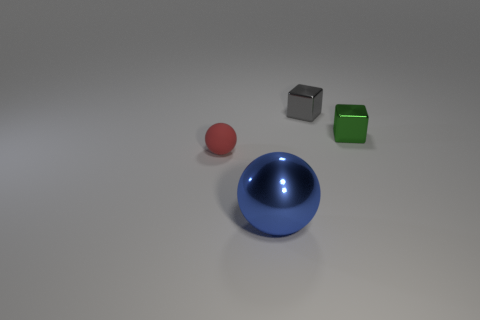Add 3 large green matte cylinders. How many objects exist? 7 Add 2 big metallic balls. How many big metallic balls are left? 3 Add 4 tiny red matte balls. How many tiny red matte balls exist? 5 Subtract 0 gray spheres. How many objects are left? 4 Subtract all large yellow matte balls. Subtract all metal balls. How many objects are left? 3 